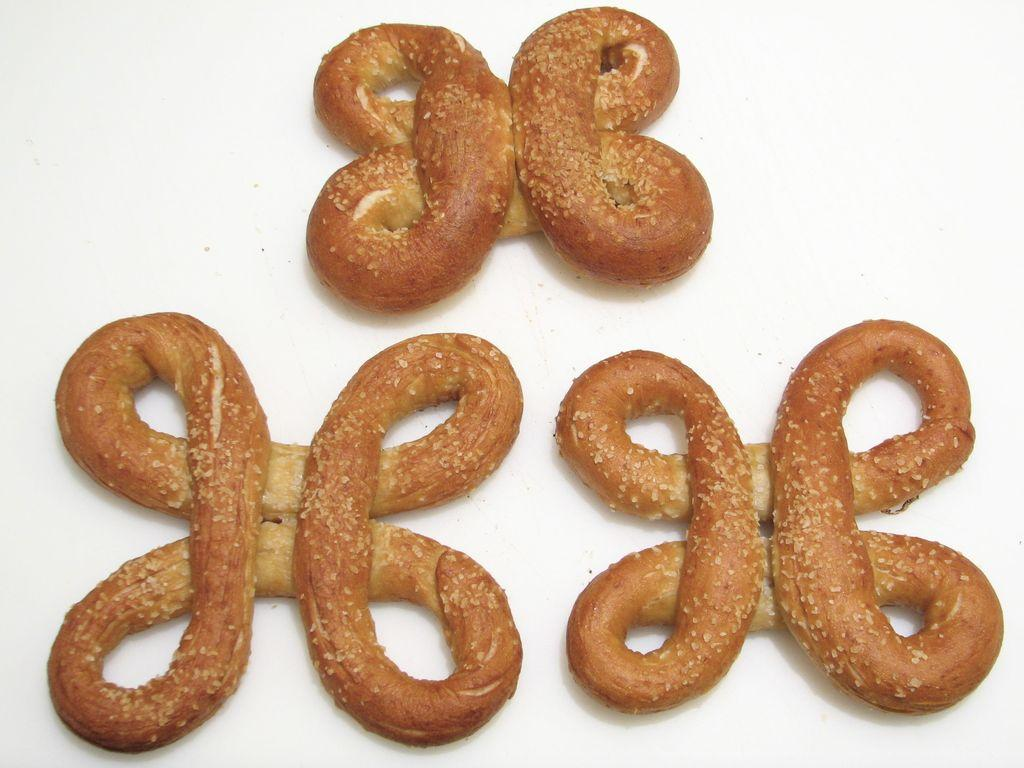What type of food can be seen in the image? There are pretzels in the image. What type of plastic invention is depicted in the image? There is no plastic invention present in the image; it features pretzels. What type of maid can be seen serving the pretzels in the image? There is no maid present in the image; it features pretzels only. 